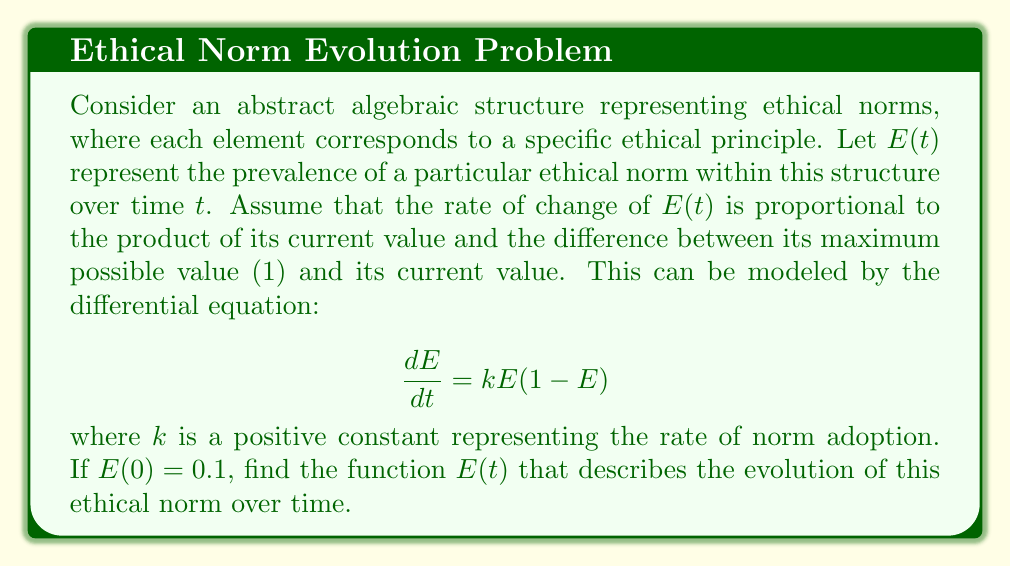Give your solution to this math problem. To solve this first-order differential equation, we can use the method of separation of variables:

1) Rewrite the equation:
   $$\frac{dE}{E(1-E)} = k dt$$

2) Integrate both sides:
   $$\int \frac{dE}{E(1-E)} = \int k dt$$

3) The left side can be decomposed using partial fractions:
   $$\int \left(\frac{1}{E} + \frac{1}{1-E}\right) dE = kt + C$$

4) Evaluate the integrals:
   $$\ln|E| - \ln|1-E| = kt + C$$

5) Simplify:
   $$\ln\left|\frac{E}{1-E}\right| = kt + C$$

6) Take the exponential of both sides:
   $$\frac{E}{1-E} = e^{kt+C} = Ae^{kt}$$, where $A = e^C$

7) Solve for $E$:
   $$E = \frac{Ae^{kt}}{1+Ae^{kt}}$$

8) Use the initial condition $E(0) = 0.1$ to find $A$:
   $$0.1 = \frac{A}{1+A}$$
   $$A = \frac{1}{9}$$

9) Substitute back into the general solution:
   $$E(t) = \frac{e^{kt}/9}{1+e^{kt}/9} = \frac{e^{kt}}{9+e^{kt}}$$

This logistic function describes the S-shaped curve characteristic of many diffusion processes, including the spread of ethical norms in this abstract algebraic structure.
Answer: $$E(t) = \frac{e^{kt}}{9+e^{kt}}$$ 